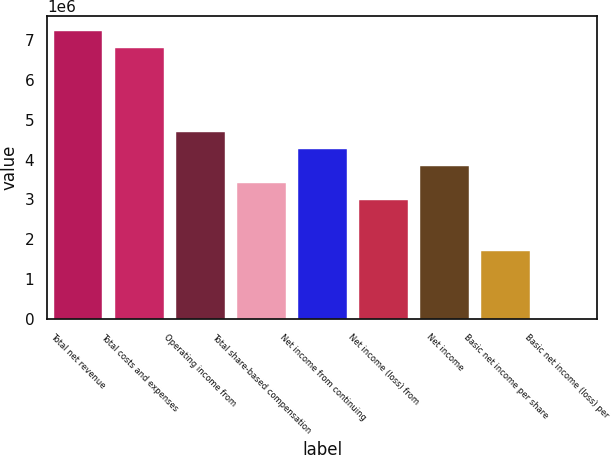<chart> <loc_0><loc_0><loc_500><loc_500><bar_chart><fcel>Total net revenue<fcel>Total costs and expenses<fcel>Operating income from<fcel>Total share-based compensation<fcel>Net income from continuing<fcel>Net income (loss) from<fcel>Net income<fcel>Basic net income per share<fcel>Basic net income (loss) per<nl><fcel>7.22844e+06<fcel>6.80324e+06<fcel>4.67723e+06<fcel>3.40162e+06<fcel>4.25203e+06<fcel>2.97642e+06<fcel>3.82682e+06<fcel>1.70081e+06<fcel>0.01<nl></chart> 